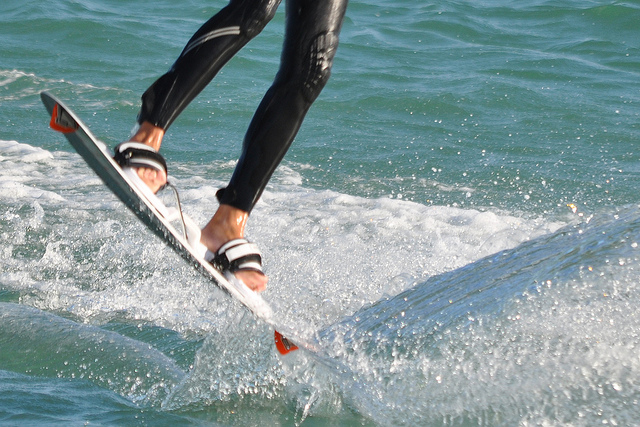What color is the water?
Answer the question using a single word or phrase. Blue Is it summer? Yes Is the person in the photo wearing tennis shoes? No 